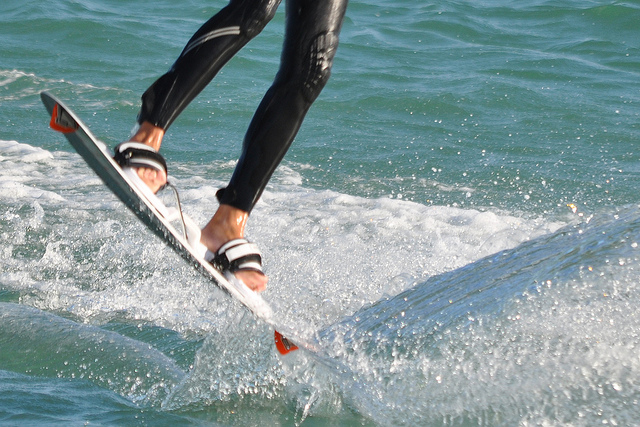What color is the water?
Answer the question using a single word or phrase. Blue Is it summer? Yes Is the person in the photo wearing tennis shoes? No 